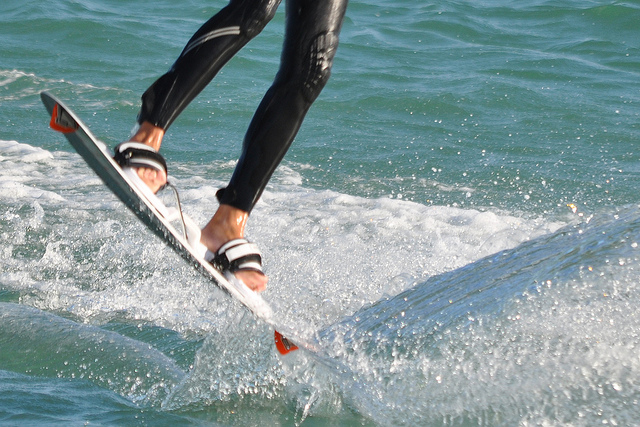What color is the water?
Answer the question using a single word or phrase. Blue Is it summer? Yes Is the person in the photo wearing tennis shoes? No 